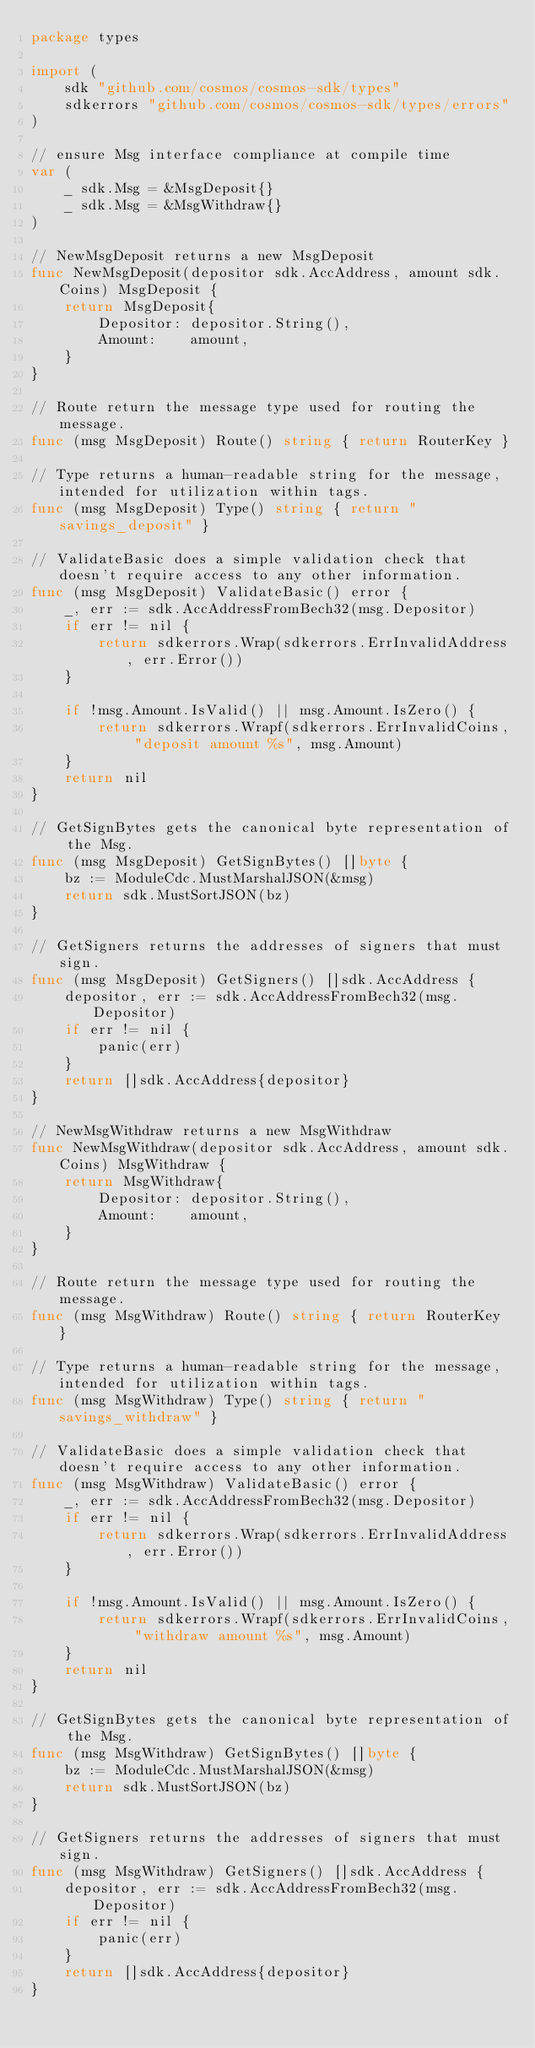<code> <loc_0><loc_0><loc_500><loc_500><_Go_>package types

import (
	sdk "github.com/cosmos/cosmos-sdk/types"
	sdkerrors "github.com/cosmos/cosmos-sdk/types/errors"
)

// ensure Msg interface compliance at compile time
var (
	_ sdk.Msg = &MsgDeposit{}
	_ sdk.Msg = &MsgWithdraw{}
)

// NewMsgDeposit returns a new MsgDeposit
func NewMsgDeposit(depositor sdk.AccAddress, amount sdk.Coins) MsgDeposit {
	return MsgDeposit{
		Depositor: depositor.String(),
		Amount:    amount,
	}
}

// Route return the message type used for routing the message.
func (msg MsgDeposit) Route() string { return RouterKey }

// Type returns a human-readable string for the message, intended for utilization within tags.
func (msg MsgDeposit) Type() string { return "savings_deposit" }

// ValidateBasic does a simple validation check that doesn't require access to any other information.
func (msg MsgDeposit) ValidateBasic() error {
	_, err := sdk.AccAddressFromBech32(msg.Depositor)
	if err != nil {
		return sdkerrors.Wrap(sdkerrors.ErrInvalidAddress, err.Error())
	}

	if !msg.Amount.IsValid() || msg.Amount.IsZero() {
		return sdkerrors.Wrapf(sdkerrors.ErrInvalidCoins, "deposit amount %s", msg.Amount)
	}
	return nil
}

// GetSignBytes gets the canonical byte representation of the Msg.
func (msg MsgDeposit) GetSignBytes() []byte {
	bz := ModuleCdc.MustMarshalJSON(&msg)
	return sdk.MustSortJSON(bz)
}

// GetSigners returns the addresses of signers that must sign.
func (msg MsgDeposit) GetSigners() []sdk.AccAddress {
	depositor, err := sdk.AccAddressFromBech32(msg.Depositor)
	if err != nil {
		panic(err)
	}
	return []sdk.AccAddress{depositor}
}

// NewMsgWithdraw returns a new MsgWithdraw
func NewMsgWithdraw(depositor sdk.AccAddress, amount sdk.Coins) MsgWithdraw {
	return MsgWithdraw{
		Depositor: depositor.String(),
		Amount:    amount,
	}
}

// Route return the message type used for routing the message.
func (msg MsgWithdraw) Route() string { return RouterKey }

// Type returns a human-readable string for the message, intended for utilization within tags.
func (msg MsgWithdraw) Type() string { return "savings_withdraw" }

// ValidateBasic does a simple validation check that doesn't require access to any other information.
func (msg MsgWithdraw) ValidateBasic() error {
	_, err := sdk.AccAddressFromBech32(msg.Depositor)
	if err != nil {
		return sdkerrors.Wrap(sdkerrors.ErrInvalidAddress, err.Error())
	}

	if !msg.Amount.IsValid() || msg.Amount.IsZero() {
		return sdkerrors.Wrapf(sdkerrors.ErrInvalidCoins, "withdraw amount %s", msg.Amount)
	}
	return nil
}

// GetSignBytes gets the canonical byte representation of the Msg.
func (msg MsgWithdraw) GetSignBytes() []byte {
	bz := ModuleCdc.MustMarshalJSON(&msg)
	return sdk.MustSortJSON(bz)
}

// GetSigners returns the addresses of signers that must sign.
func (msg MsgWithdraw) GetSigners() []sdk.AccAddress {
	depositor, err := sdk.AccAddressFromBech32(msg.Depositor)
	if err != nil {
		panic(err)
	}
	return []sdk.AccAddress{depositor}
}
</code> 